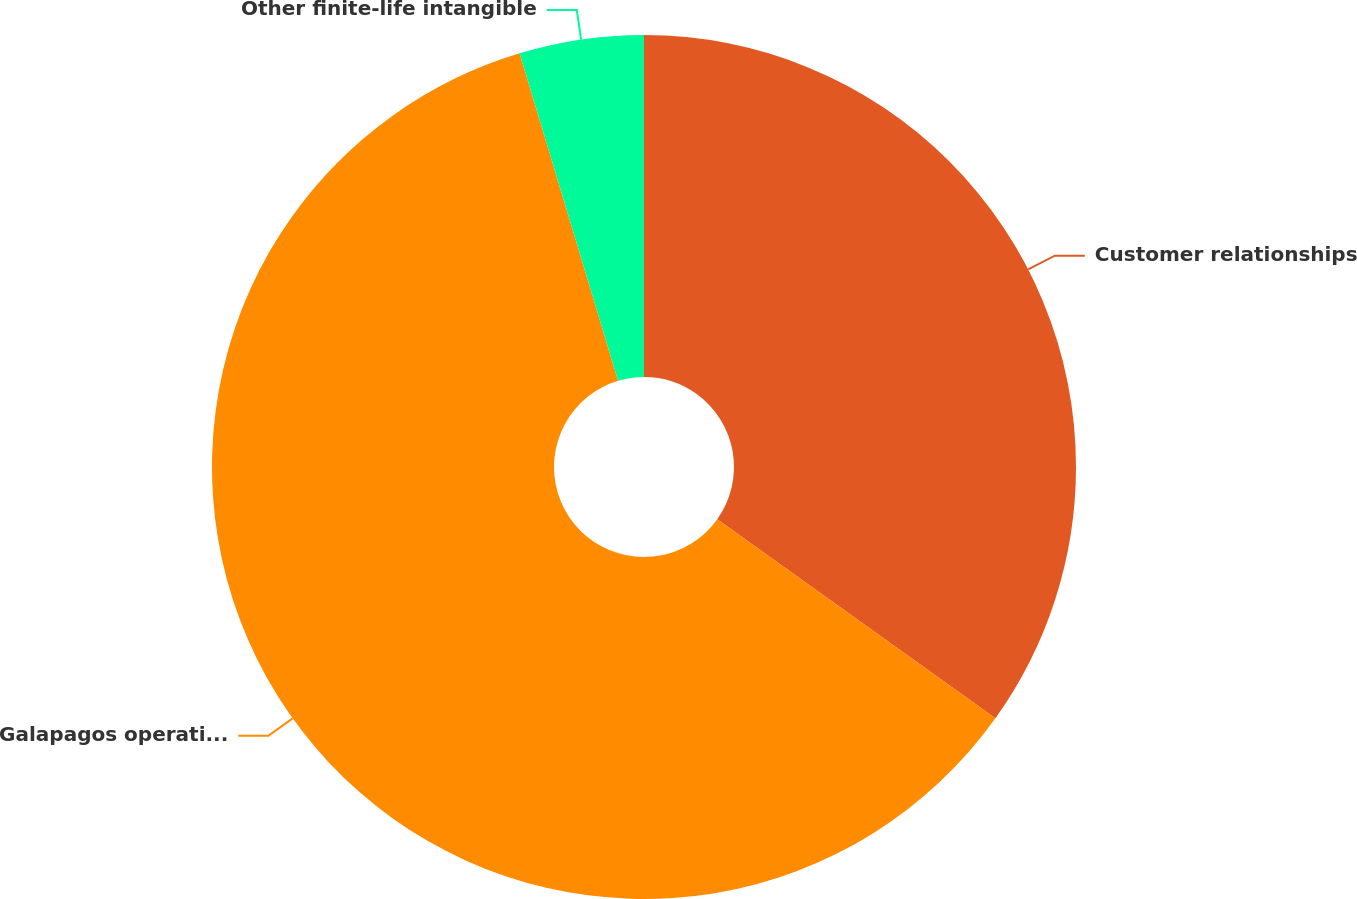<chart> <loc_0><loc_0><loc_500><loc_500><pie_chart><fcel>Customer relationships<fcel>Galapagos operating license<fcel>Other finite-life intangible<nl><fcel>34.88%<fcel>60.47%<fcel>4.65%<nl></chart> 